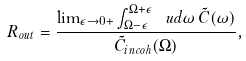Convert formula to latex. <formula><loc_0><loc_0><loc_500><loc_500>R _ { o u t } = \frac { \lim _ { \epsilon \rightarrow 0 + } \int _ { \Omega - \epsilon } ^ { \Omega + \epsilon } \ u d \omega \, \tilde { C } ( \omega ) } { \tilde { C } _ { i n c o h } ( \Omega ) } ,</formula> 